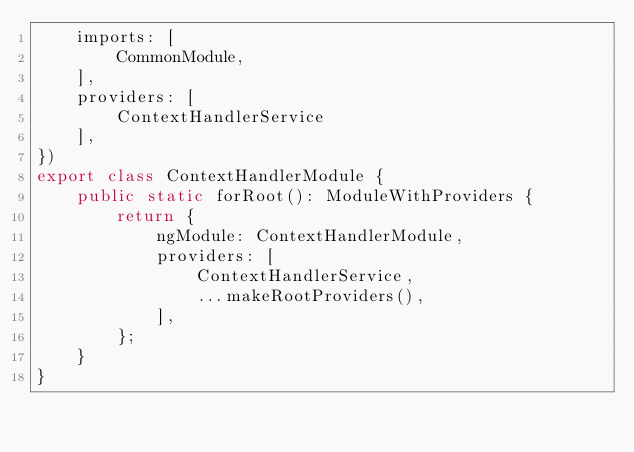<code> <loc_0><loc_0><loc_500><loc_500><_TypeScript_>    imports: [
        CommonModule,
    ],
    providers: [
        ContextHandlerService
    ],
})
export class ContextHandlerModule {
    public static forRoot(): ModuleWithProviders {
        return {
            ngModule: ContextHandlerModule,
            providers: [
                ContextHandlerService,
                ...makeRootProviders(),
            ],
        };
    }
}
</code> 